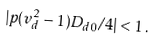<formula> <loc_0><loc_0><loc_500><loc_500>| p ( v _ { d } ^ { 2 } - 1 ) D _ { d 0 } / 4 | < 1 \, .</formula> 